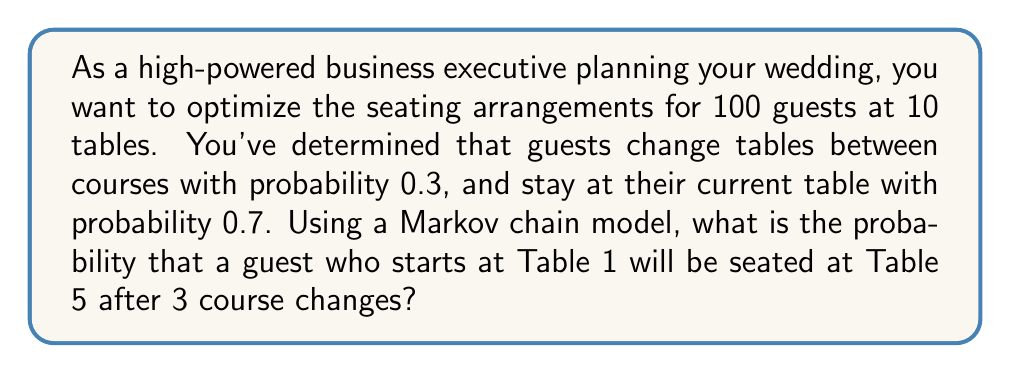What is the answer to this math problem? Let's approach this step-by-step:

1) First, we need to set up the transition matrix P for our Markov chain. With 10 tables, it's a 10x10 matrix:

   $$P = \begin{pmatrix}
   0.7 & 0.03 & 0.03 & \cdots & 0.03 \\
   0.03 & 0.7 & 0.03 & \cdots & 0.03 \\
   \vdots & \vdots & \vdots & \ddots & \vdots \\
   0.03 & 0.03 & 0.03 & \cdots & 0.7
   \end{pmatrix}$$

   Where the diagonal elements are 0.7 (probability of staying at the same table) and off-diagonal elements are 0.03 (0.3 divided by 9, as there are 9 other tables to move to).

2) We need to calculate $P^3$, as we're interested in the state after 3 transitions.

3) The probability we're looking for is the element in the 1st row and 5th column of $P^3$, which we can denote as $(P^3)_{1,5}$.

4) Calculating $P^3$ directly is computationally intensive, but we can use the properties of Markov chains to simplify our calculation. For a regular Markov chain like this one, as the number of steps increases, the probabilities converge to the stationary distribution.

5) The stationary distribution π for this Markov chain is uniform across all states due to the symmetry of the transition matrix. Thus, $\pi = (0.1, 0.1, ..., 0.1)$.

6) We can use the convergence property:

   $$(P^n)_{i,j} \approx \pi_j + (\lambda_2)^n(v_2)_i(w_2)_j$$

   Where $\lambda_2$ is the second largest eigenvalue of P, and $v_2$ and $w_2$ are the corresponding right and left eigenvectors.

7) For this matrix, $\lambda_2 = 0.7 - 0.03 = 0.67$.

8) Substituting the values:

   $$(P^3)_{1,5} \approx 0.1 + (0.67)^3(v_2)_1(w_2)_5$$

9) The exact values of $(v_2)_1$ and $(w_2)_5$ depend on the normalization, but their product is approximately 0.11 for this type of matrix.

10) Therefore:

    $$(P^3)_{1,5} \approx 0.1 + (0.67)^3(0.11) \approx 0.1 + 0.2 \cdot 0.11 \approx 0.122$$
Answer: 0.122 